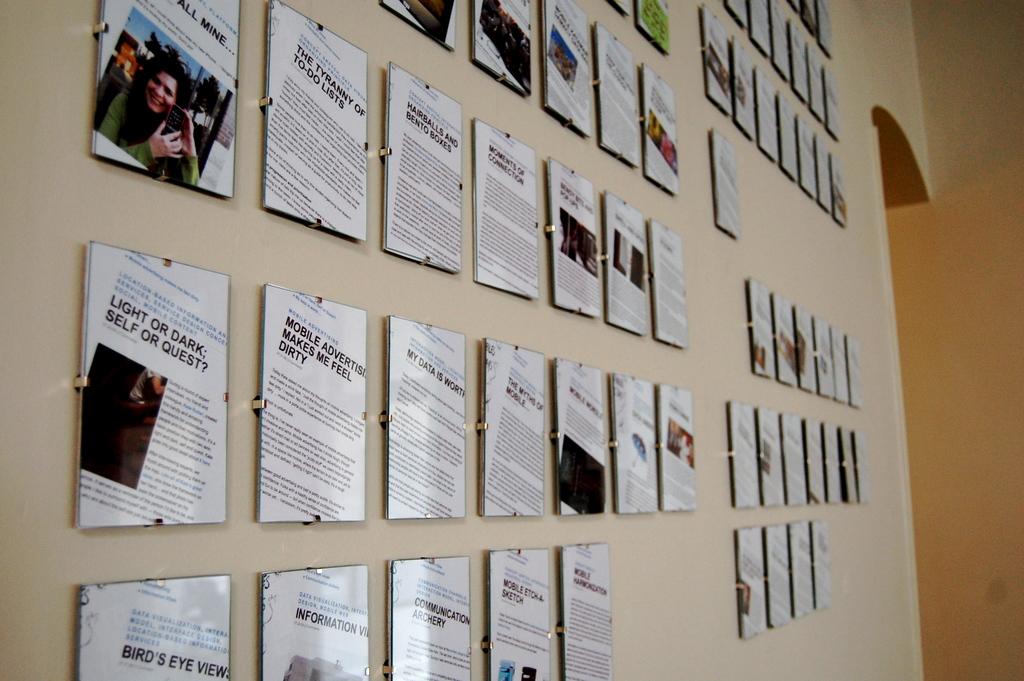What are these plaques on the wall saying?
Provide a succinct answer. Light or dark. What kind of views are featured on the bottom left plaque?
Provide a short and direct response. Bird's eye views. 